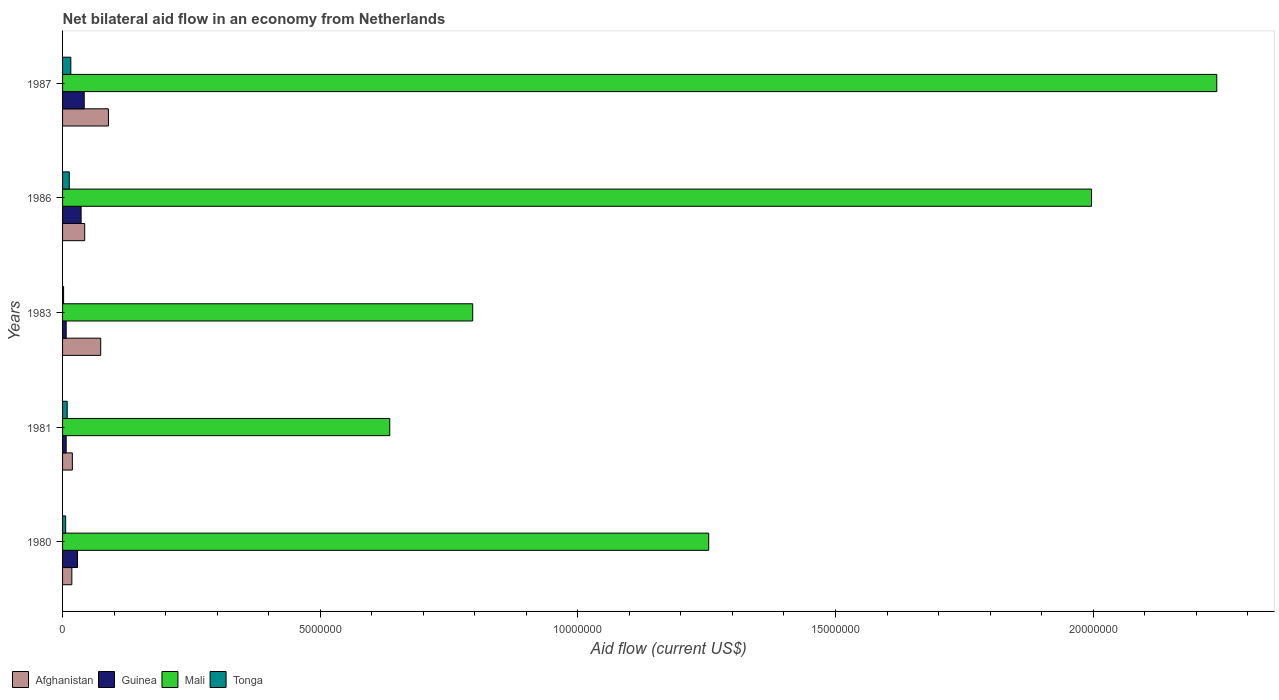How many different coloured bars are there?
Your answer should be compact. 4. How many groups of bars are there?
Keep it short and to the point. 5. Are the number of bars on each tick of the Y-axis equal?
Provide a succinct answer. Yes. How many bars are there on the 5th tick from the bottom?
Keep it short and to the point. 4. What is the label of the 3rd group of bars from the top?
Your answer should be compact. 1983. In how many cases, is the number of bars for a given year not equal to the number of legend labels?
Offer a terse response. 0. Across all years, what is the maximum net bilateral aid flow in Tonga?
Keep it short and to the point. 1.60e+05. In which year was the net bilateral aid flow in Afghanistan maximum?
Provide a succinct answer. 1987. In which year was the net bilateral aid flow in Afghanistan minimum?
Ensure brevity in your answer.  1980. What is the difference between the net bilateral aid flow in Tonga in 1981 and that in 1986?
Ensure brevity in your answer.  -4.00e+04. What is the difference between the net bilateral aid flow in Mali in 1981 and the net bilateral aid flow in Afghanistan in 1983?
Make the answer very short. 5.61e+06. What is the average net bilateral aid flow in Tonga per year?
Give a very brief answer. 9.20e+04. In the year 1980, what is the difference between the net bilateral aid flow in Tonga and net bilateral aid flow in Mali?
Offer a very short reply. -1.25e+07. What is the ratio of the net bilateral aid flow in Guinea in 1981 to that in 1983?
Provide a short and direct response. 1. Is the difference between the net bilateral aid flow in Tonga in 1983 and 1987 greater than the difference between the net bilateral aid flow in Mali in 1983 and 1987?
Your answer should be very brief. Yes. What is the difference between the highest and the lowest net bilateral aid flow in Mali?
Provide a short and direct response. 1.60e+07. In how many years, is the net bilateral aid flow in Guinea greater than the average net bilateral aid flow in Guinea taken over all years?
Keep it short and to the point. 3. Is the sum of the net bilateral aid flow in Guinea in 1983 and 1987 greater than the maximum net bilateral aid flow in Mali across all years?
Your response must be concise. No. What does the 3rd bar from the top in 1983 represents?
Your response must be concise. Guinea. What does the 4th bar from the bottom in 1983 represents?
Make the answer very short. Tonga. Is it the case that in every year, the sum of the net bilateral aid flow in Tonga and net bilateral aid flow in Afghanistan is greater than the net bilateral aid flow in Mali?
Offer a terse response. No. How many bars are there?
Ensure brevity in your answer.  20. Are all the bars in the graph horizontal?
Provide a succinct answer. Yes. Are the values on the major ticks of X-axis written in scientific E-notation?
Offer a terse response. No. Does the graph contain any zero values?
Provide a succinct answer. No. What is the title of the graph?
Ensure brevity in your answer.  Net bilateral aid flow in an economy from Netherlands. What is the label or title of the Y-axis?
Ensure brevity in your answer.  Years. What is the Aid flow (current US$) in Mali in 1980?
Give a very brief answer. 1.25e+07. What is the Aid flow (current US$) in Tonga in 1980?
Provide a short and direct response. 6.00e+04. What is the Aid flow (current US$) in Afghanistan in 1981?
Offer a very short reply. 1.90e+05. What is the Aid flow (current US$) of Guinea in 1981?
Your response must be concise. 7.00e+04. What is the Aid flow (current US$) in Mali in 1981?
Your response must be concise. 6.35e+06. What is the Aid flow (current US$) of Afghanistan in 1983?
Provide a short and direct response. 7.40e+05. What is the Aid flow (current US$) of Guinea in 1983?
Provide a succinct answer. 7.00e+04. What is the Aid flow (current US$) of Mali in 1983?
Your answer should be compact. 7.96e+06. What is the Aid flow (current US$) in Tonga in 1983?
Your answer should be very brief. 2.00e+04. What is the Aid flow (current US$) of Mali in 1986?
Give a very brief answer. 2.00e+07. What is the Aid flow (current US$) of Tonga in 1986?
Your answer should be very brief. 1.30e+05. What is the Aid flow (current US$) in Afghanistan in 1987?
Give a very brief answer. 8.90e+05. What is the Aid flow (current US$) in Guinea in 1987?
Provide a succinct answer. 4.20e+05. What is the Aid flow (current US$) in Mali in 1987?
Offer a very short reply. 2.24e+07. Across all years, what is the maximum Aid flow (current US$) in Afghanistan?
Make the answer very short. 8.90e+05. Across all years, what is the maximum Aid flow (current US$) in Guinea?
Your answer should be compact. 4.20e+05. Across all years, what is the maximum Aid flow (current US$) in Mali?
Your answer should be very brief. 2.24e+07. Across all years, what is the maximum Aid flow (current US$) in Tonga?
Your answer should be very brief. 1.60e+05. Across all years, what is the minimum Aid flow (current US$) in Guinea?
Provide a succinct answer. 7.00e+04. Across all years, what is the minimum Aid flow (current US$) of Mali?
Your answer should be compact. 6.35e+06. Across all years, what is the minimum Aid flow (current US$) in Tonga?
Give a very brief answer. 2.00e+04. What is the total Aid flow (current US$) in Afghanistan in the graph?
Keep it short and to the point. 2.43e+06. What is the total Aid flow (current US$) in Guinea in the graph?
Your response must be concise. 1.21e+06. What is the total Aid flow (current US$) of Mali in the graph?
Offer a terse response. 6.92e+07. What is the difference between the Aid flow (current US$) in Mali in 1980 and that in 1981?
Ensure brevity in your answer.  6.19e+06. What is the difference between the Aid flow (current US$) of Tonga in 1980 and that in 1981?
Provide a succinct answer. -3.00e+04. What is the difference between the Aid flow (current US$) in Afghanistan in 1980 and that in 1983?
Keep it short and to the point. -5.60e+05. What is the difference between the Aid flow (current US$) of Mali in 1980 and that in 1983?
Your response must be concise. 4.58e+06. What is the difference between the Aid flow (current US$) of Tonga in 1980 and that in 1983?
Provide a short and direct response. 4.00e+04. What is the difference between the Aid flow (current US$) of Mali in 1980 and that in 1986?
Offer a terse response. -7.43e+06. What is the difference between the Aid flow (current US$) in Tonga in 1980 and that in 1986?
Your response must be concise. -7.00e+04. What is the difference between the Aid flow (current US$) of Afghanistan in 1980 and that in 1987?
Make the answer very short. -7.10e+05. What is the difference between the Aid flow (current US$) in Guinea in 1980 and that in 1987?
Offer a terse response. -1.30e+05. What is the difference between the Aid flow (current US$) of Mali in 1980 and that in 1987?
Your answer should be very brief. -9.86e+06. What is the difference between the Aid flow (current US$) in Tonga in 1980 and that in 1987?
Your answer should be compact. -1.00e+05. What is the difference between the Aid flow (current US$) of Afghanistan in 1981 and that in 1983?
Provide a succinct answer. -5.50e+05. What is the difference between the Aid flow (current US$) in Mali in 1981 and that in 1983?
Offer a very short reply. -1.61e+06. What is the difference between the Aid flow (current US$) in Mali in 1981 and that in 1986?
Make the answer very short. -1.36e+07. What is the difference between the Aid flow (current US$) in Tonga in 1981 and that in 1986?
Your answer should be very brief. -4.00e+04. What is the difference between the Aid flow (current US$) in Afghanistan in 1981 and that in 1987?
Provide a succinct answer. -7.00e+05. What is the difference between the Aid flow (current US$) of Guinea in 1981 and that in 1987?
Your answer should be compact. -3.50e+05. What is the difference between the Aid flow (current US$) of Mali in 1981 and that in 1987?
Provide a short and direct response. -1.60e+07. What is the difference between the Aid flow (current US$) in Tonga in 1981 and that in 1987?
Offer a terse response. -7.00e+04. What is the difference between the Aid flow (current US$) of Mali in 1983 and that in 1986?
Provide a succinct answer. -1.20e+07. What is the difference between the Aid flow (current US$) of Afghanistan in 1983 and that in 1987?
Ensure brevity in your answer.  -1.50e+05. What is the difference between the Aid flow (current US$) of Guinea in 1983 and that in 1987?
Keep it short and to the point. -3.50e+05. What is the difference between the Aid flow (current US$) of Mali in 1983 and that in 1987?
Make the answer very short. -1.44e+07. What is the difference between the Aid flow (current US$) of Afghanistan in 1986 and that in 1987?
Offer a terse response. -4.60e+05. What is the difference between the Aid flow (current US$) in Guinea in 1986 and that in 1987?
Ensure brevity in your answer.  -6.00e+04. What is the difference between the Aid flow (current US$) in Mali in 1986 and that in 1987?
Ensure brevity in your answer.  -2.43e+06. What is the difference between the Aid flow (current US$) in Afghanistan in 1980 and the Aid flow (current US$) in Guinea in 1981?
Your answer should be compact. 1.10e+05. What is the difference between the Aid flow (current US$) of Afghanistan in 1980 and the Aid flow (current US$) of Mali in 1981?
Your response must be concise. -6.17e+06. What is the difference between the Aid flow (current US$) of Afghanistan in 1980 and the Aid flow (current US$) of Tonga in 1981?
Make the answer very short. 9.00e+04. What is the difference between the Aid flow (current US$) of Guinea in 1980 and the Aid flow (current US$) of Mali in 1981?
Make the answer very short. -6.06e+06. What is the difference between the Aid flow (current US$) of Mali in 1980 and the Aid flow (current US$) of Tonga in 1981?
Your answer should be compact. 1.24e+07. What is the difference between the Aid flow (current US$) in Afghanistan in 1980 and the Aid flow (current US$) in Mali in 1983?
Keep it short and to the point. -7.78e+06. What is the difference between the Aid flow (current US$) in Guinea in 1980 and the Aid flow (current US$) in Mali in 1983?
Offer a terse response. -7.67e+06. What is the difference between the Aid flow (current US$) of Mali in 1980 and the Aid flow (current US$) of Tonga in 1983?
Offer a very short reply. 1.25e+07. What is the difference between the Aid flow (current US$) in Afghanistan in 1980 and the Aid flow (current US$) in Guinea in 1986?
Offer a terse response. -1.80e+05. What is the difference between the Aid flow (current US$) in Afghanistan in 1980 and the Aid flow (current US$) in Mali in 1986?
Provide a succinct answer. -1.98e+07. What is the difference between the Aid flow (current US$) of Guinea in 1980 and the Aid flow (current US$) of Mali in 1986?
Offer a very short reply. -1.97e+07. What is the difference between the Aid flow (current US$) in Guinea in 1980 and the Aid flow (current US$) in Tonga in 1986?
Give a very brief answer. 1.60e+05. What is the difference between the Aid flow (current US$) of Mali in 1980 and the Aid flow (current US$) of Tonga in 1986?
Make the answer very short. 1.24e+07. What is the difference between the Aid flow (current US$) in Afghanistan in 1980 and the Aid flow (current US$) in Mali in 1987?
Ensure brevity in your answer.  -2.22e+07. What is the difference between the Aid flow (current US$) of Afghanistan in 1980 and the Aid flow (current US$) of Tonga in 1987?
Give a very brief answer. 2.00e+04. What is the difference between the Aid flow (current US$) of Guinea in 1980 and the Aid flow (current US$) of Mali in 1987?
Provide a short and direct response. -2.21e+07. What is the difference between the Aid flow (current US$) of Guinea in 1980 and the Aid flow (current US$) of Tonga in 1987?
Provide a short and direct response. 1.30e+05. What is the difference between the Aid flow (current US$) in Mali in 1980 and the Aid flow (current US$) in Tonga in 1987?
Your answer should be compact. 1.24e+07. What is the difference between the Aid flow (current US$) in Afghanistan in 1981 and the Aid flow (current US$) in Guinea in 1983?
Provide a succinct answer. 1.20e+05. What is the difference between the Aid flow (current US$) of Afghanistan in 1981 and the Aid flow (current US$) of Mali in 1983?
Your answer should be very brief. -7.77e+06. What is the difference between the Aid flow (current US$) in Afghanistan in 1981 and the Aid flow (current US$) in Tonga in 1983?
Ensure brevity in your answer.  1.70e+05. What is the difference between the Aid flow (current US$) of Guinea in 1981 and the Aid flow (current US$) of Mali in 1983?
Make the answer very short. -7.89e+06. What is the difference between the Aid flow (current US$) in Guinea in 1981 and the Aid flow (current US$) in Tonga in 1983?
Give a very brief answer. 5.00e+04. What is the difference between the Aid flow (current US$) in Mali in 1981 and the Aid flow (current US$) in Tonga in 1983?
Your answer should be very brief. 6.33e+06. What is the difference between the Aid flow (current US$) in Afghanistan in 1981 and the Aid flow (current US$) in Guinea in 1986?
Give a very brief answer. -1.70e+05. What is the difference between the Aid flow (current US$) of Afghanistan in 1981 and the Aid flow (current US$) of Mali in 1986?
Ensure brevity in your answer.  -1.98e+07. What is the difference between the Aid flow (current US$) in Afghanistan in 1981 and the Aid flow (current US$) in Tonga in 1986?
Make the answer very short. 6.00e+04. What is the difference between the Aid flow (current US$) of Guinea in 1981 and the Aid flow (current US$) of Mali in 1986?
Make the answer very short. -1.99e+07. What is the difference between the Aid flow (current US$) in Guinea in 1981 and the Aid flow (current US$) in Tonga in 1986?
Offer a terse response. -6.00e+04. What is the difference between the Aid flow (current US$) of Mali in 1981 and the Aid flow (current US$) of Tonga in 1986?
Offer a very short reply. 6.22e+06. What is the difference between the Aid flow (current US$) in Afghanistan in 1981 and the Aid flow (current US$) in Mali in 1987?
Offer a very short reply. -2.22e+07. What is the difference between the Aid flow (current US$) in Guinea in 1981 and the Aid flow (current US$) in Mali in 1987?
Provide a succinct answer. -2.23e+07. What is the difference between the Aid flow (current US$) of Mali in 1981 and the Aid flow (current US$) of Tonga in 1987?
Provide a short and direct response. 6.19e+06. What is the difference between the Aid flow (current US$) in Afghanistan in 1983 and the Aid flow (current US$) in Mali in 1986?
Offer a terse response. -1.92e+07. What is the difference between the Aid flow (current US$) in Guinea in 1983 and the Aid flow (current US$) in Mali in 1986?
Make the answer very short. -1.99e+07. What is the difference between the Aid flow (current US$) of Guinea in 1983 and the Aid flow (current US$) of Tonga in 1986?
Provide a short and direct response. -6.00e+04. What is the difference between the Aid flow (current US$) of Mali in 1983 and the Aid flow (current US$) of Tonga in 1986?
Your answer should be very brief. 7.83e+06. What is the difference between the Aid flow (current US$) of Afghanistan in 1983 and the Aid flow (current US$) of Guinea in 1987?
Your answer should be very brief. 3.20e+05. What is the difference between the Aid flow (current US$) in Afghanistan in 1983 and the Aid flow (current US$) in Mali in 1987?
Your answer should be very brief. -2.17e+07. What is the difference between the Aid flow (current US$) of Afghanistan in 1983 and the Aid flow (current US$) of Tonga in 1987?
Offer a terse response. 5.80e+05. What is the difference between the Aid flow (current US$) of Guinea in 1983 and the Aid flow (current US$) of Mali in 1987?
Offer a terse response. -2.23e+07. What is the difference between the Aid flow (current US$) in Mali in 1983 and the Aid flow (current US$) in Tonga in 1987?
Your answer should be very brief. 7.80e+06. What is the difference between the Aid flow (current US$) of Afghanistan in 1986 and the Aid flow (current US$) of Mali in 1987?
Ensure brevity in your answer.  -2.20e+07. What is the difference between the Aid flow (current US$) in Afghanistan in 1986 and the Aid flow (current US$) in Tonga in 1987?
Provide a short and direct response. 2.70e+05. What is the difference between the Aid flow (current US$) in Guinea in 1986 and the Aid flow (current US$) in Mali in 1987?
Offer a terse response. -2.20e+07. What is the difference between the Aid flow (current US$) in Mali in 1986 and the Aid flow (current US$) in Tonga in 1987?
Your answer should be compact. 1.98e+07. What is the average Aid flow (current US$) in Afghanistan per year?
Keep it short and to the point. 4.86e+05. What is the average Aid flow (current US$) in Guinea per year?
Give a very brief answer. 2.42e+05. What is the average Aid flow (current US$) in Mali per year?
Provide a short and direct response. 1.38e+07. What is the average Aid flow (current US$) of Tonga per year?
Offer a terse response. 9.20e+04. In the year 1980, what is the difference between the Aid flow (current US$) of Afghanistan and Aid flow (current US$) of Mali?
Provide a succinct answer. -1.24e+07. In the year 1980, what is the difference between the Aid flow (current US$) in Afghanistan and Aid flow (current US$) in Tonga?
Make the answer very short. 1.20e+05. In the year 1980, what is the difference between the Aid flow (current US$) of Guinea and Aid flow (current US$) of Mali?
Offer a very short reply. -1.22e+07. In the year 1980, what is the difference between the Aid flow (current US$) of Mali and Aid flow (current US$) of Tonga?
Your answer should be compact. 1.25e+07. In the year 1981, what is the difference between the Aid flow (current US$) of Afghanistan and Aid flow (current US$) of Guinea?
Your answer should be very brief. 1.20e+05. In the year 1981, what is the difference between the Aid flow (current US$) of Afghanistan and Aid flow (current US$) of Mali?
Give a very brief answer. -6.16e+06. In the year 1981, what is the difference between the Aid flow (current US$) of Afghanistan and Aid flow (current US$) of Tonga?
Make the answer very short. 1.00e+05. In the year 1981, what is the difference between the Aid flow (current US$) in Guinea and Aid flow (current US$) in Mali?
Ensure brevity in your answer.  -6.28e+06. In the year 1981, what is the difference between the Aid flow (current US$) in Mali and Aid flow (current US$) in Tonga?
Your response must be concise. 6.26e+06. In the year 1983, what is the difference between the Aid flow (current US$) of Afghanistan and Aid flow (current US$) of Guinea?
Provide a short and direct response. 6.70e+05. In the year 1983, what is the difference between the Aid flow (current US$) in Afghanistan and Aid flow (current US$) in Mali?
Your answer should be compact. -7.22e+06. In the year 1983, what is the difference between the Aid flow (current US$) of Afghanistan and Aid flow (current US$) of Tonga?
Ensure brevity in your answer.  7.20e+05. In the year 1983, what is the difference between the Aid flow (current US$) in Guinea and Aid flow (current US$) in Mali?
Offer a very short reply. -7.89e+06. In the year 1983, what is the difference between the Aid flow (current US$) in Guinea and Aid flow (current US$) in Tonga?
Your response must be concise. 5.00e+04. In the year 1983, what is the difference between the Aid flow (current US$) in Mali and Aid flow (current US$) in Tonga?
Give a very brief answer. 7.94e+06. In the year 1986, what is the difference between the Aid flow (current US$) of Afghanistan and Aid flow (current US$) of Mali?
Your response must be concise. -1.95e+07. In the year 1986, what is the difference between the Aid flow (current US$) in Guinea and Aid flow (current US$) in Mali?
Your response must be concise. -1.96e+07. In the year 1986, what is the difference between the Aid flow (current US$) of Mali and Aid flow (current US$) of Tonga?
Provide a short and direct response. 1.98e+07. In the year 1987, what is the difference between the Aid flow (current US$) of Afghanistan and Aid flow (current US$) of Guinea?
Your response must be concise. 4.70e+05. In the year 1987, what is the difference between the Aid flow (current US$) in Afghanistan and Aid flow (current US$) in Mali?
Provide a succinct answer. -2.15e+07. In the year 1987, what is the difference between the Aid flow (current US$) of Afghanistan and Aid flow (current US$) of Tonga?
Make the answer very short. 7.30e+05. In the year 1987, what is the difference between the Aid flow (current US$) of Guinea and Aid flow (current US$) of Mali?
Your response must be concise. -2.20e+07. In the year 1987, what is the difference between the Aid flow (current US$) of Mali and Aid flow (current US$) of Tonga?
Keep it short and to the point. 2.22e+07. What is the ratio of the Aid flow (current US$) in Afghanistan in 1980 to that in 1981?
Your answer should be very brief. 0.95. What is the ratio of the Aid flow (current US$) in Guinea in 1980 to that in 1981?
Your answer should be very brief. 4.14. What is the ratio of the Aid flow (current US$) in Mali in 1980 to that in 1981?
Provide a succinct answer. 1.97. What is the ratio of the Aid flow (current US$) of Afghanistan in 1980 to that in 1983?
Offer a very short reply. 0.24. What is the ratio of the Aid flow (current US$) in Guinea in 1980 to that in 1983?
Offer a very short reply. 4.14. What is the ratio of the Aid flow (current US$) of Mali in 1980 to that in 1983?
Give a very brief answer. 1.58. What is the ratio of the Aid flow (current US$) in Afghanistan in 1980 to that in 1986?
Your answer should be very brief. 0.42. What is the ratio of the Aid flow (current US$) in Guinea in 1980 to that in 1986?
Your answer should be very brief. 0.81. What is the ratio of the Aid flow (current US$) in Mali in 1980 to that in 1986?
Provide a short and direct response. 0.63. What is the ratio of the Aid flow (current US$) of Tonga in 1980 to that in 1986?
Make the answer very short. 0.46. What is the ratio of the Aid flow (current US$) of Afghanistan in 1980 to that in 1987?
Provide a succinct answer. 0.2. What is the ratio of the Aid flow (current US$) in Guinea in 1980 to that in 1987?
Offer a very short reply. 0.69. What is the ratio of the Aid flow (current US$) in Mali in 1980 to that in 1987?
Offer a very short reply. 0.56. What is the ratio of the Aid flow (current US$) in Tonga in 1980 to that in 1987?
Give a very brief answer. 0.38. What is the ratio of the Aid flow (current US$) in Afghanistan in 1981 to that in 1983?
Offer a very short reply. 0.26. What is the ratio of the Aid flow (current US$) in Mali in 1981 to that in 1983?
Offer a terse response. 0.8. What is the ratio of the Aid flow (current US$) of Tonga in 1981 to that in 1983?
Provide a succinct answer. 4.5. What is the ratio of the Aid flow (current US$) of Afghanistan in 1981 to that in 1986?
Give a very brief answer. 0.44. What is the ratio of the Aid flow (current US$) in Guinea in 1981 to that in 1986?
Make the answer very short. 0.19. What is the ratio of the Aid flow (current US$) in Mali in 1981 to that in 1986?
Keep it short and to the point. 0.32. What is the ratio of the Aid flow (current US$) of Tonga in 1981 to that in 1986?
Offer a very short reply. 0.69. What is the ratio of the Aid flow (current US$) in Afghanistan in 1981 to that in 1987?
Offer a terse response. 0.21. What is the ratio of the Aid flow (current US$) in Guinea in 1981 to that in 1987?
Your response must be concise. 0.17. What is the ratio of the Aid flow (current US$) in Mali in 1981 to that in 1987?
Keep it short and to the point. 0.28. What is the ratio of the Aid flow (current US$) in Tonga in 1981 to that in 1987?
Your response must be concise. 0.56. What is the ratio of the Aid flow (current US$) in Afghanistan in 1983 to that in 1986?
Your response must be concise. 1.72. What is the ratio of the Aid flow (current US$) in Guinea in 1983 to that in 1986?
Give a very brief answer. 0.19. What is the ratio of the Aid flow (current US$) of Mali in 1983 to that in 1986?
Keep it short and to the point. 0.4. What is the ratio of the Aid flow (current US$) of Tonga in 1983 to that in 1986?
Provide a short and direct response. 0.15. What is the ratio of the Aid flow (current US$) of Afghanistan in 1983 to that in 1987?
Make the answer very short. 0.83. What is the ratio of the Aid flow (current US$) in Mali in 1983 to that in 1987?
Give a very brief answer. 0.36. What is the ratio of the Aid flow (current US$) in Tonga in 1983 to that in 1987?
Ensure brevity in your answer.  0.12. What is the ratio of the Aid flow (current US$) in Afghanistan in 1986 to that in 1987?
Give a very brief answer. 0.48. What is the ratio of the Aid flow (current US$) in Guinea in 1986 to that in 1987?
Make the answer very short. 0.86. What is the ratio of the Aid flow (current US$) of Mali in 1986 to that in 1987?
Your response must be concise. 0.89. What is the ratio of the Aid flow (current US$) of Tonga in 1986 to that in 1987?
Offer a very short reply. 0.81. What is the difference between the highest and the second highest Aid flow (current US$) in Afghanistan?
Your answer should be very brief. 1.50e+05. What is the difference between the highest and the second highest Aid flow (current US$) in Guinea?
Ensure brevity in your answer.  6.00e+04. What is the difference between the highest and the second highest Aid flow (current US$) in Mali?
Your answer should be compact. 2.43e+06. What is the difference between the highest and the lowest Aid flow (current US$) of Afghanistan?
Your response must be concise. 7.10e+05. What is the difference between the highest and the lowest Aid flow (current US$) in Mali?
Give a very brief answer. 1.60e+07. 